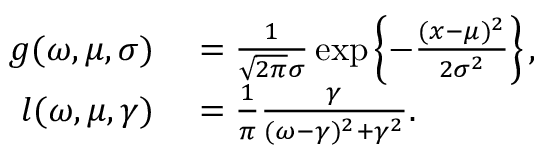<formula> <loc_0><loc_0><loc_500><loc_500>\begin{array} { r l } { g ( \omega , \mu , \sigma ) } & = \frac { 1 } { \sqrt { 2 \pi } \sigma } \exp \left \{ - \frac { ( x - \mu ) ^ { 2 } } { 2 \sigma ^ { 2 } } \right \} , } \\ { l ( \omega , \mu , \gamma ) } & = \frac { 1 } { \pi } \frac { \gamma } { ( \omega - \gamma ) ^ { 2 } + \gamma ^ { 2 } } . } \end{array}</formula> 